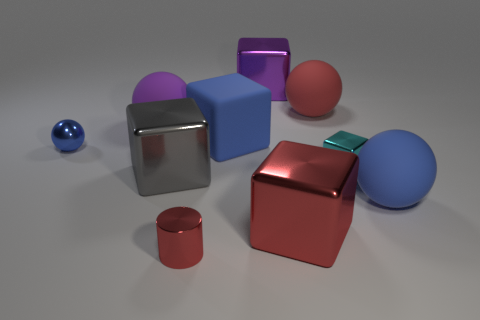Subtract all tiny cubes. How many cubes are left? 4 Subtract all purple balls. How many balls are left? 3 Subtract all blue spheres. How many red cubes are left? 1 Add 3 green shiny cubes. How many green shiny cubes exist? 3 Subtract 0 yellow cubes. How many objects are left? 10 Subtract all cylinders. How many objects are left? 9 Subtract 1 cylinders. How many cylinders are left? 0 Subtract all yellow cylinders. Subtract all red spheres. How many cylinders are left? 1 Subtract all red shiny things. Subtract all tiny cyan matte blocks. How many objects are left? 8 Add 7 tiny blue spheres. How many tiny blue spheres are left? 8 